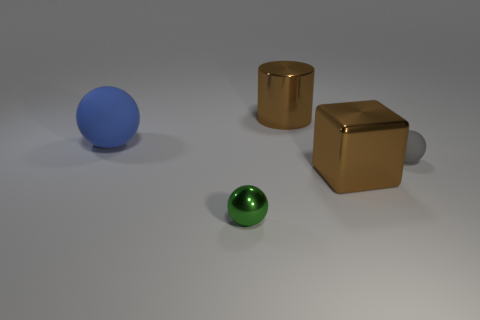Add 3 shiny cubes. How many objects exist? 8 Subtract all cylinders. How many objects are left? 4 Add 2 large green cylinders. How many large green cylinders exist? 2 Subtract 0 green cylinders. How many objects are left? 5 Subtract all large matte objects. Subtract all big brown shiny objects. How many objects are left? 2 Add 4 brown metal cubes. How many brown metal cubes are left? 5 